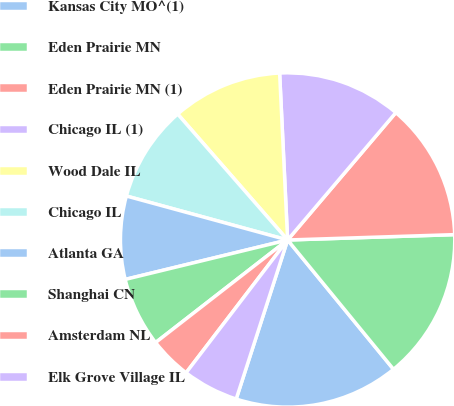Convert chart to OTSL. <chart><loc_0><loc_0><loc_500><loc_500><pie_chart><fcel>Kansas City MO^(1)<fcel>Eden Prairie MN<fcel>Eden Prairie MN (1)<fcel>Chicago IL (1)<fcel>Wood Dale IL<fcel>Chicago IL<fcel>Atlanta GA<fcel>Shanghai CN<fcel>Amsterdam NL<fcel>Elk Grove Village IL<nl><fcel>15.9%<fcel>14.59%<fcel>13.28%<fcel>11.97%<fcel>10.66%<fcel>9.34%<fcel>8.03%<fcel>6.72%<fcel>4.1%<fcel>5.41%<nl></chart> 